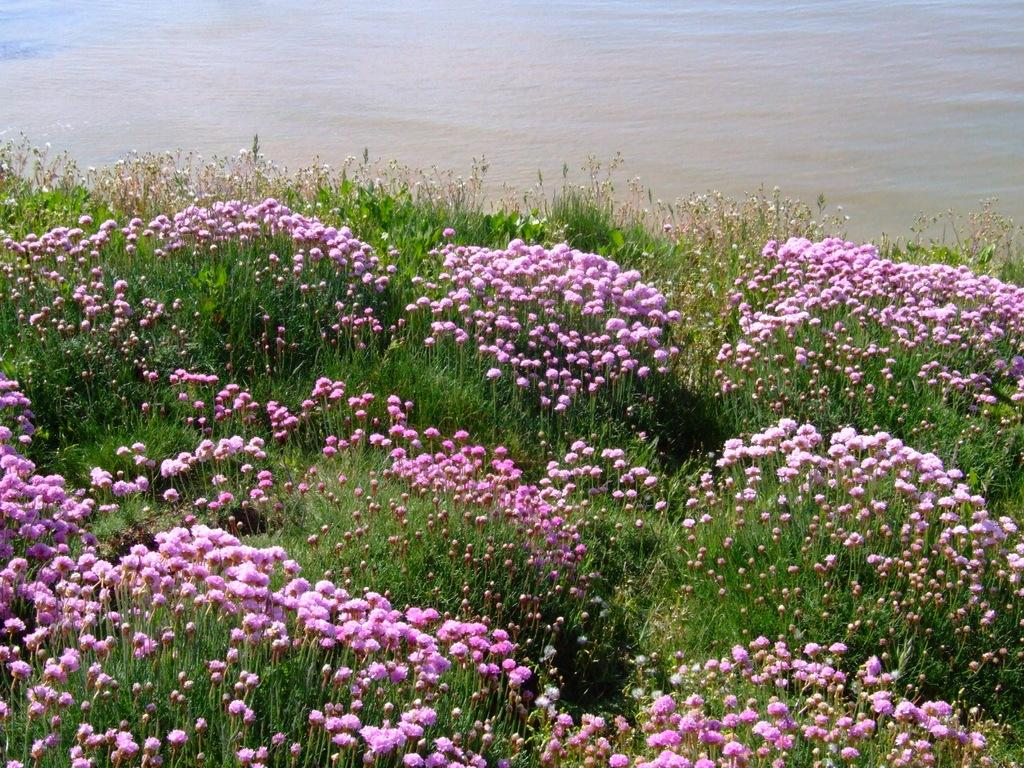What type of plants are present in the image? There are plants with flowers in the image. Can you describe the water visible in the image? The water is visible at the top of the image. What type of quill can be seen writing a message in the image? There is no quill present in the image; it features plants with flowers and water. How does the image demonstrate respect for the environment? The image itself does not demonstrate respect for the environment, as it is a static representation of plants and water. Respect for the environment is a concept that can be demonstrated through actions and behaviors, not through an image. 